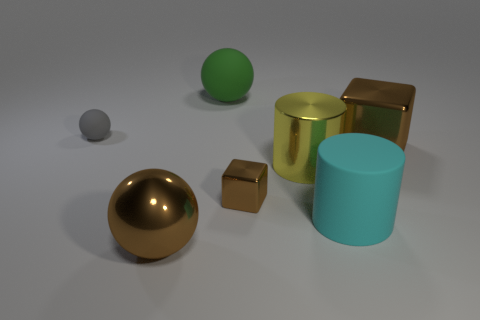What purpose might these objects serve in a real-life setting? The objects shown in the image seem like conceptual 3D models and probably aren't functional in a real-world context. However, their shapes - spheres, cylinders, and cubes - often serve as basic components in various design and engineering applications, aiding in visualizations, prototyping, and educational demonstrations of geometric principles. 